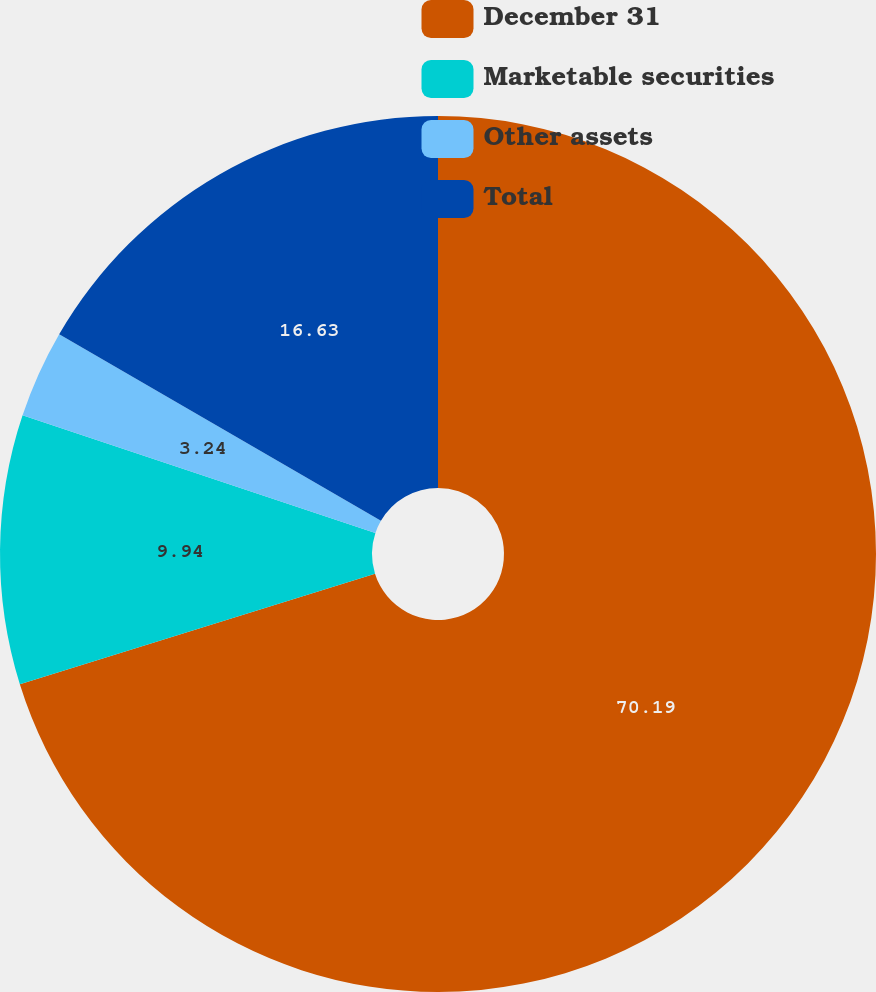<chart> <loc_0><loc_0><loc_500><loc_500><pie_chart><fcel>December 31<fcel>Marketable securities<fcel>Other assets<fcel>Total<nl><fcel>70.19%<fcel>9.94%<fcel>3.24%<fcel>16.63%<nl></chart> 